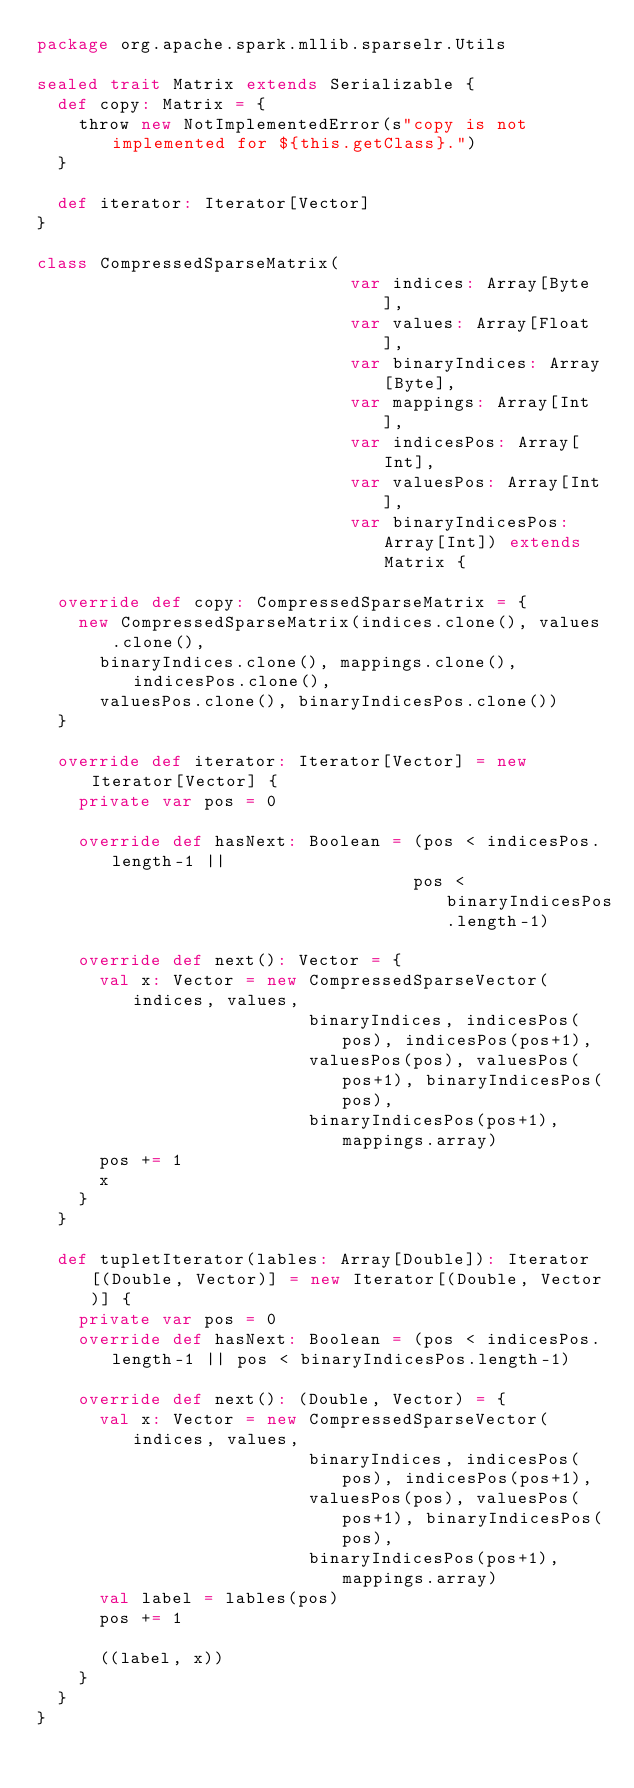<code> <loc_0><loc_0><loc_500><loc_500><_Scala_>package org.apache.spark.mllib.sparselr.Utils

sealed trait Matrix extends Serializable {
  def copy: Matrix = {
    throw new NotImplementedError(s"copy is not implemented for ${this.getClass}.")
  }

  def iterator: Iterator[Vector]
}

class CompressedSparseMatrix(
                              var indices: Array[Byte],
                              var values: Array[Float],
                              var binaryIndices: Array[Byte],
                              var mappings: Array[Int],
                              var indicesPos: Array[Int],
                              var valuesPos: Array[Int],
                              var binaryIndicesPos: Array[Int]) extends Matrix {

  override def copy: CompressedSparseMatrix = {
    new CompressedSparseMatrix(indices.clone(), values.clone(),
      binaryIndices.clone(), mappings.clone(), indicesPos.clone(),
      valuesPos.clone(), binaryIndicesPos.clone())
  }

  override def iterator: Iterator[Vector] = new Iterator[Vector] {
    private var pos = 0

    override def hasNext: Boolean = (pos < indicesPos.length-1 ||
                                    pos < binaryIndicesPos.length-1)

    override def next(): Vector = {
      val x: Vector = new CompressedSparseVector(indices, values,
                          binaryIndices, indicesPos(pos), indicesPos(pos+1),
                          valuesPos(pos), valuesPos(pos+1), binaryIndicesPos(pos),
                          binaryIndicesPos(pos+1), mappings.array)
      pos += 1
      x
    }
  }

  def tupletIterator(lables: Array[Double]): Iterator[(Double, Vector)] = new Iterator[(Double, Vector)] {
    private var pos = 0
    override def hasNext: Boolean = (pos < indicesPos.length-1 || pos < binaryIndicesPos.length-1)

    override def next(): (Double, Vector) = {
      val x: Vector = new CompressedSparseVector(indices, values,
                          binaryIndices, indicesPos(pos), indicesPos(pos+1),
                          valuesPos(pos), valuesPos(pos+1), binaryIndicesPos(pos),
                          binaryIndicesPos(pos+1), mappings.array)
      val label = lables(pos)
      pos += 1

      ((label, x))
    }
  }
}</code> 